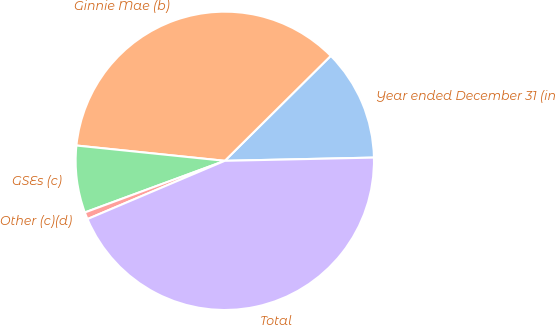<chart> <loc_0><loc_0><loc_500><loc_500><pie_chart><fcel>Year ended December 31 (in<fcel>Ginnie Mae (b)<fcel>GSEs (c)<fcel>Other (c)(d)<fcel>Total<nl><fcel>12.08%<fcel>35.94%<fcel>7.26%<fcel>0.76%<fcel>43.96%<nl></chart> 